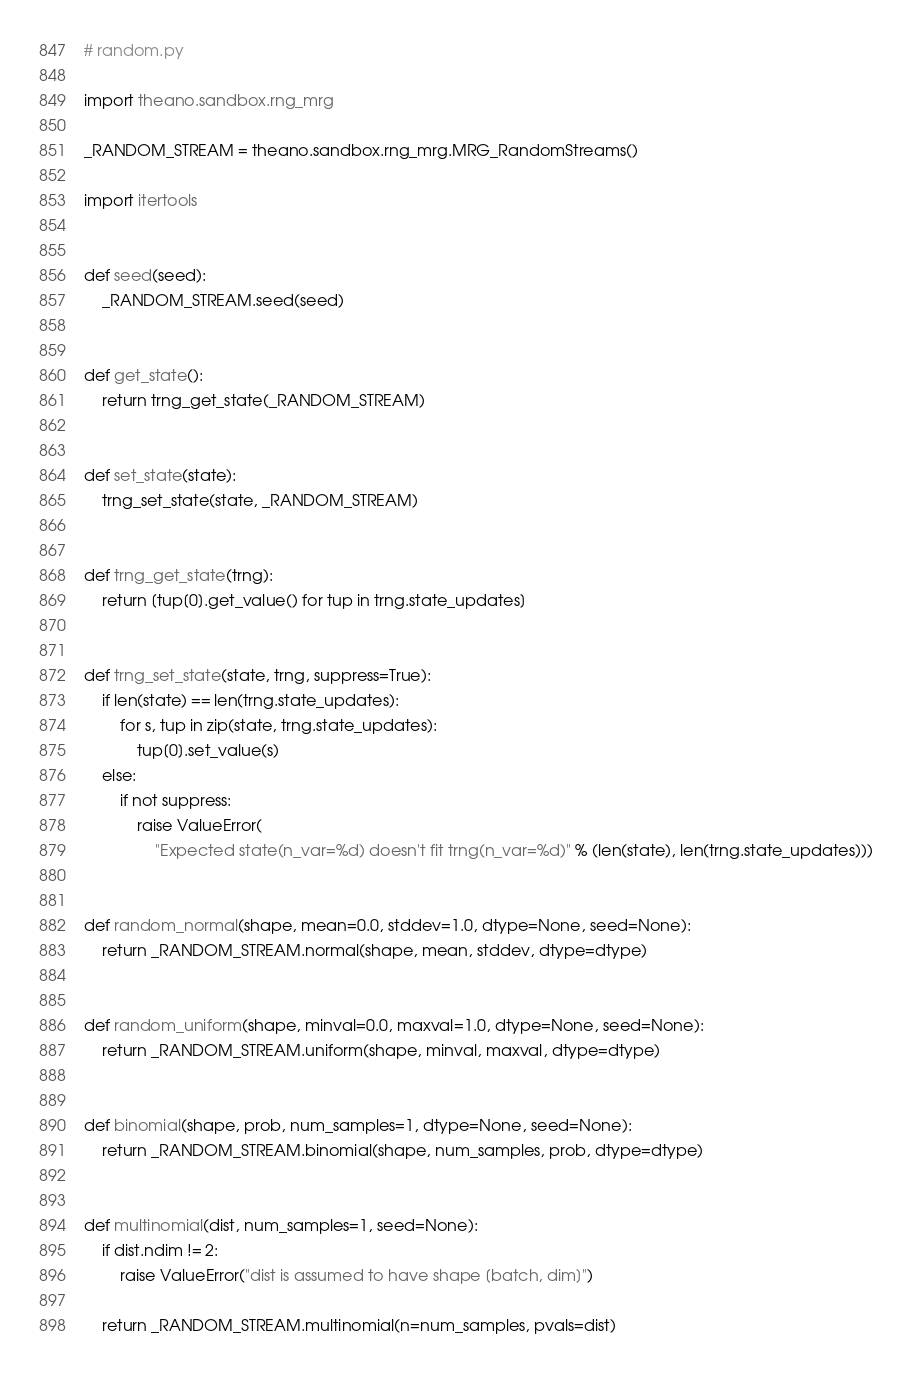Convert code to text. <code><loc_0><loc_0><loc_500><loc_500><_Python_># random.py

import theano.sandbox.rng_mrg

_RANDOM_STREAM = theano.sandbox.rng_mrg.MRG_RandomStreams()

import itertools


def seed(seed):
    _RANDOM_STREAM.seed(seed)


def get_state():
    return trng_get_state(_RANDOM_STREAM)


def set_state(state):
    trng_set_state(state, _RANDOM_STREAM)


def trng_get_state(trng):
    return [tup[0].get_value() for tup in trng.state_updates]


def trng_set_state(state, trng, suppress=True):
    if len(state) == len(trng.state_updates):
        for s, tup in zip(state, trng.state_updates):
            tup[0].set_value(s)
    else:
        if not suppress:
            raise ValueError(
                "Expected state(n_var=%d) doesn't fit trng(n_var=%d)" % (len(state), len(trng.state_updates)))


def random_normal(shape, mean=0.0, stddev=1.0, dtype=None, seed=None):
    return _RANDOM_STREAM.normal(shape, mean, stddev, dtype=dtype)


def random_uniform(shape, minval=0.0, maxval=1.0, dtype=None, seed=None):
    return _RANDOM_STREAM.uniform(shape, minval, maxval, dtype=dtype)


def binomial(shape, prob, num_samples=1, dtype=None, seed=None):
    return _RANDOM_STREAM.binomial(shape, num_samples, prob, dtype=dtype)


def multinomial(dist, num_samples=1, seed=None):
    if dist.ndim != 2:
        raise ValueError("dist is assumed to have shape [batch, dim]")

    return _RANDOM_STREAM.multinomial(n=num_samples, pvals=dist)
</code> 